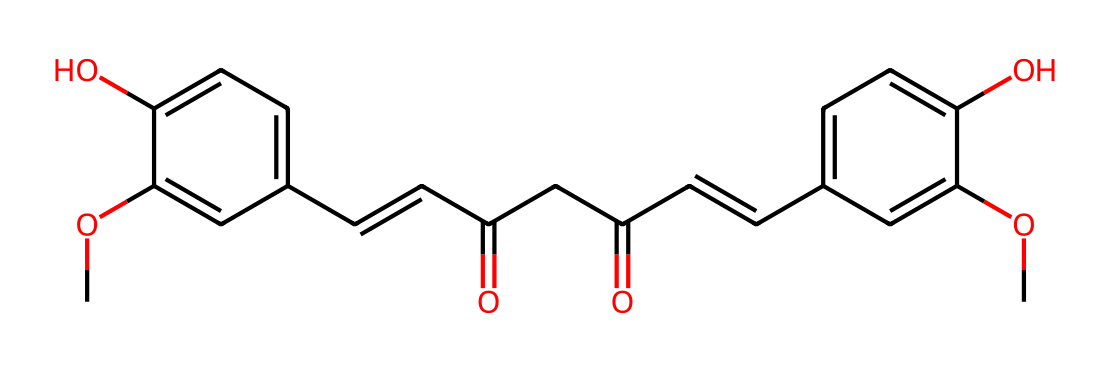What is the molecular formula of curcumin? By analyzing the given SMILES representation, we can count the number of different atoms present. The formula includes Carbon (C), Hydrogen (H), and Oxygen (O) atoms. In total, we find there are 21 Carbon atoms, 20 Hydrogen atoms, and 6 Oxygen atoms, leading to the molecular formula C21H20O6.
Answer: C21H20O6 How many rings are present in the curcumin structure? Looking closely at the SMILES representation, we can identify the presence of two rings in the structure. The notation indicates locations where bonds connect in a cyclic manner, confirming that they form two distinct aromatic rings.
Answer: 2 Which functional groups are identified in curcumin? By interpreting the SMILES formula, we can identify the functional groups present in the structure. Notably, the presence of hydroxyl (-OH) groups and carbonyl (C=O) groups is clear. This indicates the presence of both phenolic and keto functional groups in curcumin.
Answer: hydroxyl and carbonyl What is the total number of double bonds in curcumin? Carefully examining the SMILES code reveals several instances of double bonds, particularly around the conjugated double bond system within the vinyl and carbonyl groups. Counting these gives a total of 6 double bonds.
Answer: 6 Is curcumin likely to act as an antioxidant? Based on its structure, curcumin has multiple phenolic hydroxyl groups which are known to have antioxidant properties. The presence of these groups suggests that it will act effectively against oxidative stress by donating electrons.
Answer: yes 